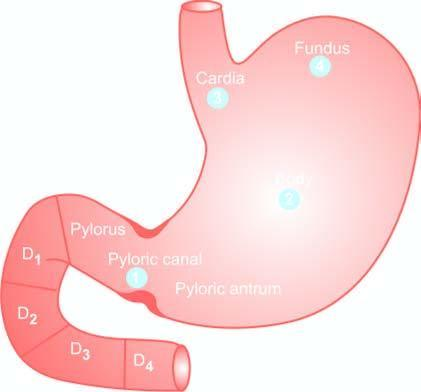what indicate the order of frequency of occurrence of gastric cancer?
Answer the question using a single word or phrase. Serial numbers in the figure 